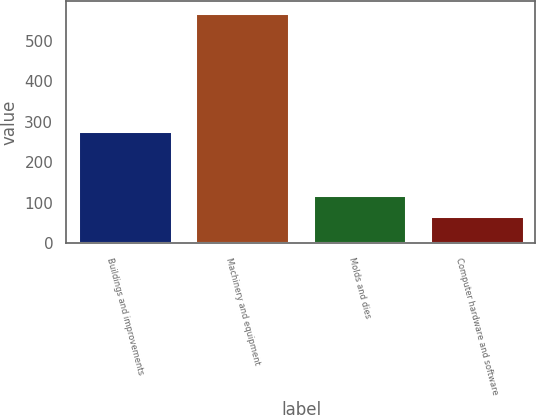Convert chart. <chart><loc_0><loc_0><loc_500><loc_500><bar_chart><fcel>Buildings and improvements<fcel>Machinery and equipment<fcel>Molds and dies<fcel>Computer hardware and software<nl><fcel>276.4<fcel>568.7<fcel>118.25<fcel>68.2<nl></chart> 